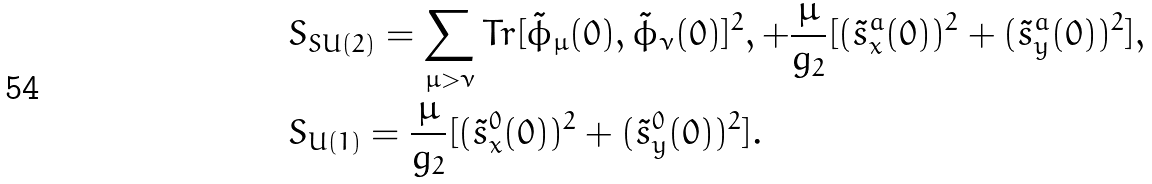<formula> <loc_0><loc_0><loc_500><loc_500>& S _ { S U ( 2 ) } = \sum _ { \mu > \nu } T r [ \tilde { \phi } _ { \mu } ( 0 ) , \tilde { \phi } _ { \nu } ( 0 ) ] ^ { 2 } , + \frac { \mu } { g _ { 2 } } [ ( \tilde { s } ^ { a } _ { x } ( 0 ) ) ^ { 2 } + ( \tilde { s } ^ { a } _ { y } ( 0 ) ) ^ { 2 } ] , \\ & S _ { U ( 1 ) } = \frac { \mu } { g _ { 2 } } [ ( \tilde { s } ^ { 0 } _ { x } ( 0 ) ) ^ { 2 } + ( \tilde { s } ^ { 0 } _ { y } ( 0 ) ) ^ { 2 } ] .</formula> 